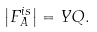Convert formula to latex. <formula><loc_0><loc_0><loc_500><loc_500>\left | F _ { A } ^ { i s } \right | = Y Q .</formula> 